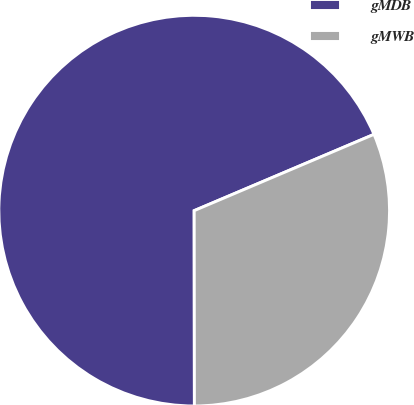Convert chart to OTSL. <chart><loc_0><loc_0><loc_500><loc_500><pie_chart><fcel>gMDB<fcel>gMWB<nl><fcel>68.63%<fcel>31.37%<nl></chart> 